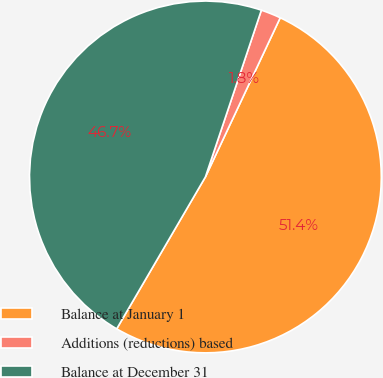Convert chart to OTSL. <chart><loc_0><loc_0><loc_500><loc_500><pie_chart><fcel>Balance at January 1<fcel>Additions (reductions) based<fcel>Balance at December 31<nl><fcel>51.42%<fcel>1.84%<fcel>46.74%<nl></chart> 